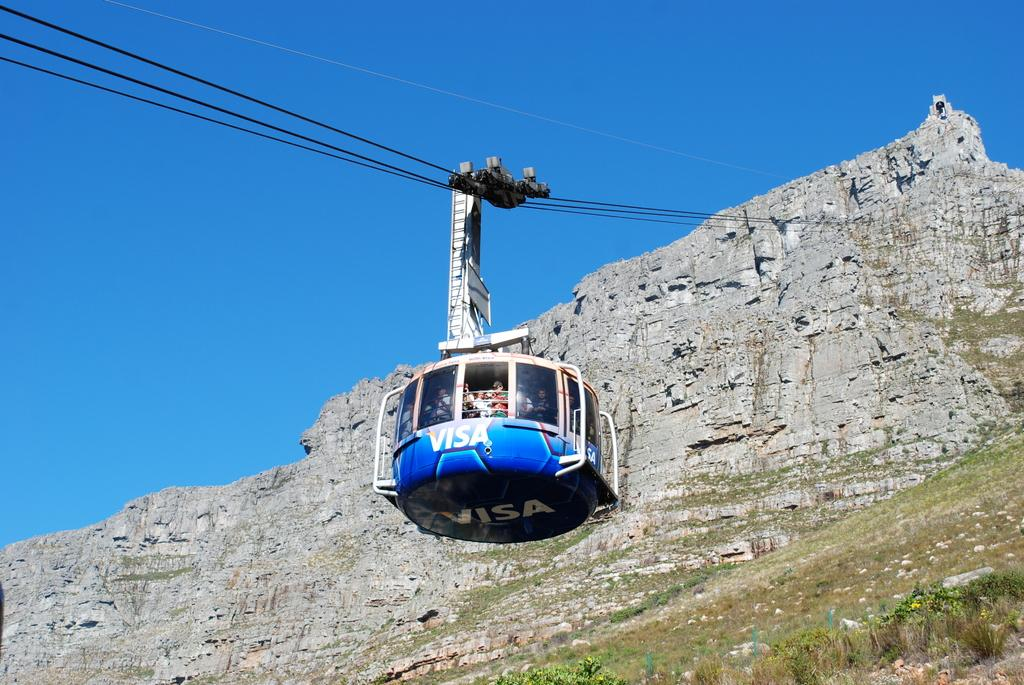What is the main subject of the image? The main subject of the image is a ropeway. Are there any people in the image? Yes, there are persons in the ropeway. What can be seen at the bottom of the ropeway? There is grass at the bottom of the ropeway. How many cattle can be seen grazing near the ropeway in the image? There are no cattle present in the image. Are the persons in the ropeway brothers? The relationship between the persons in the ropeway cannot be determined from the image. 